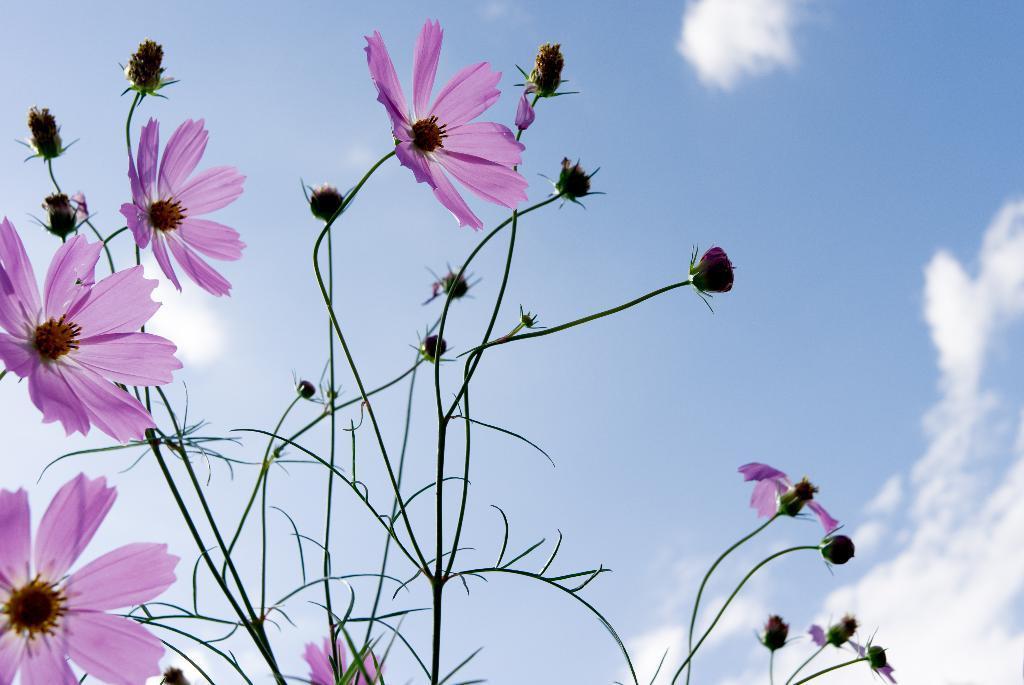Could you give a brief overview of what you see in this image? In the middle of the image we can see a plant and flowers. Behind the plant we can see some clouds in the sky. 